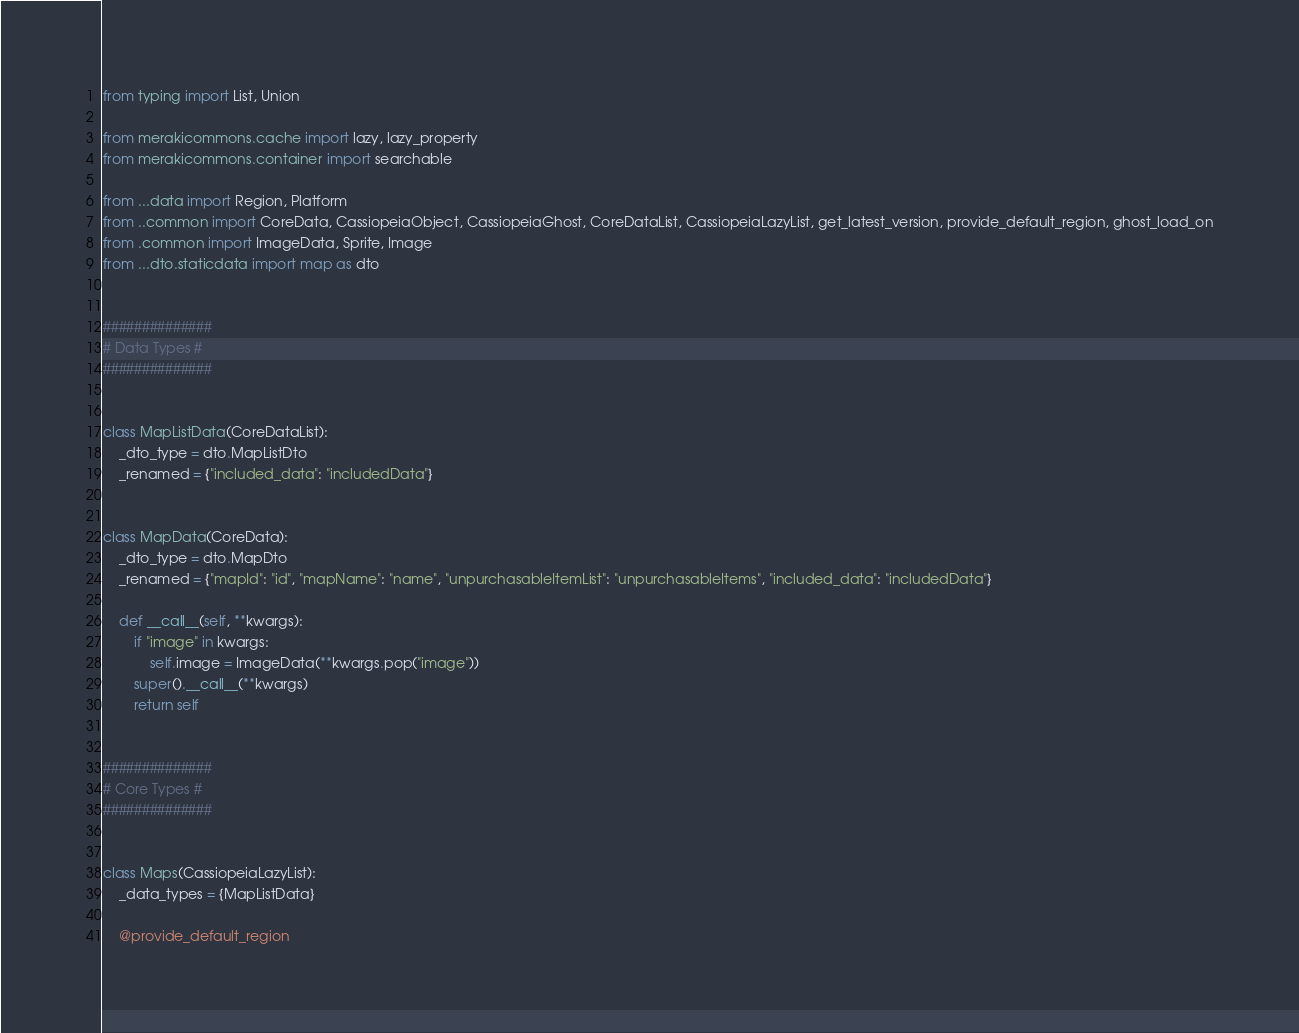<code> <loc_0><loc_0><loc_500><loc_500><_Python_>from typing import List, Union

from merakicommons.cache import lazy, lazy_property
from merakicommons.container import searchable

from ...data import Region, Platform
from ..common import CoreData, CassiopeiaObject, CassiopeiaGhost, CoreDataList, CassiopeiaLazyList, get_latest_version, provide_default_region, ghost_load_on
from .common import ImageData, Sprite, Image
from ...dto.staticdata import map as dto


##############
# Data Types #
##############


class MapListData(CoreDataList):
    _dto_type = dto.MapListDto
    _renamed = {"included_data": "includedData"}


class MapData(CoreData):
    _dto_type = dto.MapDto
    _renamed = {"mapId": "id", "mapName": "name", "unpurchasableItemList": "unpurchasableItems", "included_data": "includedData"}

    def __call__(self, **kwargs):
        if "image" in kwargs:
            self.image = ImageData(**kwargs.pop("image"))
        super().__call__(**kwargs)
        return self


##############
# Core Types #
##############


class Maps(CassiopeiaLazyList):
    _data_types = {MapListData}

    @provide_default_region</code> 